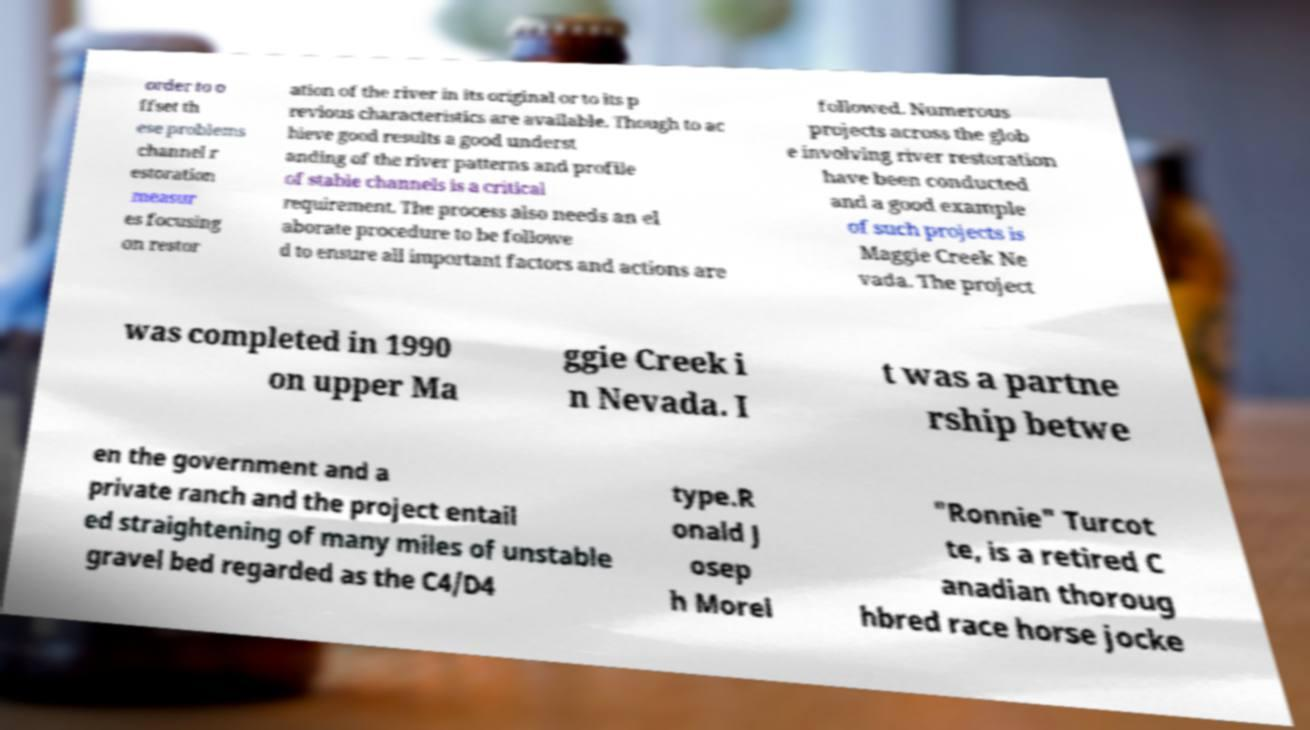What messages or text are displayed in this image? I need them in a readable, typed format. order to o ffset th ese problems channel r estoration measur es focusing on restor ation of the river in its original or to its p revious characteristics are available. Though to ac hieve good results a good underst anding of the river patterns and profile of stable channels is a critical requirement. The process also needs an el aborate procedure to be followe d to ensure all important factors and actions are followed. Numerous projects across the glob e involving river restoration have been conducted and a good example of such projects is Maggie Creek Ne vada. The project was completed in 1990 on upper Ma ggie Creek i n Nevada. I t was a partne rship betwe en the government and a private ranch and the project entail ed straightening of many miles of unstable gravel bed regarded as the C4/D4 type.R onald J osep h Morel "Ronnie" Turcot te, is a retired C anadian thoroug hbred race horse jocke 